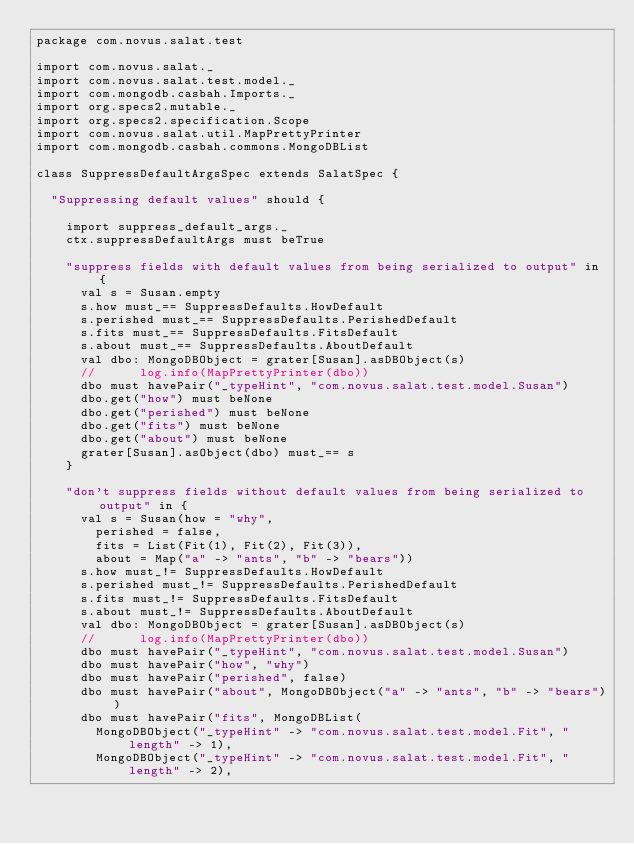Convert code to text. <code><loc_0><loc_0><loc_500><loc_500><_Scala_>package com.novus.salat.test

import com.novus.salat._
import com.novus.salat.test.model._
import com.mongodb.casbah.Imports._
import org.specs2.mutable._
import org.specs2.specification.Scope
import com.novus.salat.util.MapPrettyPrinter
import com.mongodb.casbah.commons.MongoDBList

class SuppressDefaultArgsSpec extends SalatSpec {

  "Suppressing default values" should {

    import suppress_default_args._
    ctx.suppressDefaultArgs must beTrue

    "suppress fields with default values from being serialized to output" in {
      val s = Susan.empty
      s.how must_== SuppressDefaults.HowDefault
      s.perished must_== SuppressDefaults.PerishedDefault
      s.fits must_== SuppressDefaults.FitsDefault
      s.about must_== SuppressDefaults.AboutDefault
      val dbo: MongoDBObject = grater[Susan].asDBObject(s)
      //      log.info(MapPrettyPrinter(dbo))
      dbo must havePair("_typeHint", "com.novus.salat.test.model.Susan")
      dbo.get("how") must beNone
      dbo.get("perished") must beNone
      dbo.get("fits") must beNone
      dbo.get("about") must beNone
      grater[Susan].asObject(dbo) must_== s
    }

    "don't suppress fields without default values from being serialized to output" in {
      val s = Susan(how = "why",
        perished = false,
        fits = List(Fit(1), Fit(2), Fit(3)),
        about = Map("a" -> "ants", "b" -> "bears"))
      s.how must_!= SuppressDefaults.HowDefault
      s.perished must_!= SuppressDefaults.PerishedDefault
      s.fits must_!= SuppressDefaults.FitsDefault
      s.about must_!= SuppressDefaults.AboutDefault
      val dbo: MongoDBObject = grater[Susan].asDBObject(s)
      //      log.info(MapPrettyPrinter(dbo))
      dbo must havePair("_typeHint", "com.novus.salat.test.model.Susan")
      dbo must havePair("how", "why")
      dbo must havePair("perished", false)
      dbo must havePair("about", MongoDBObject("a" -> "ants", "b" -> "bears"))
      dbo must havePair("fits", MongoDBList(
        MongoDBObject("_typeHint" -> "com.novus.salat.test.model.Fit", "length" -> 1),
        MongoDBObject("_typeHint" -> "com.novus.salat.test.model.Fit", "length" -> 2),</code> 